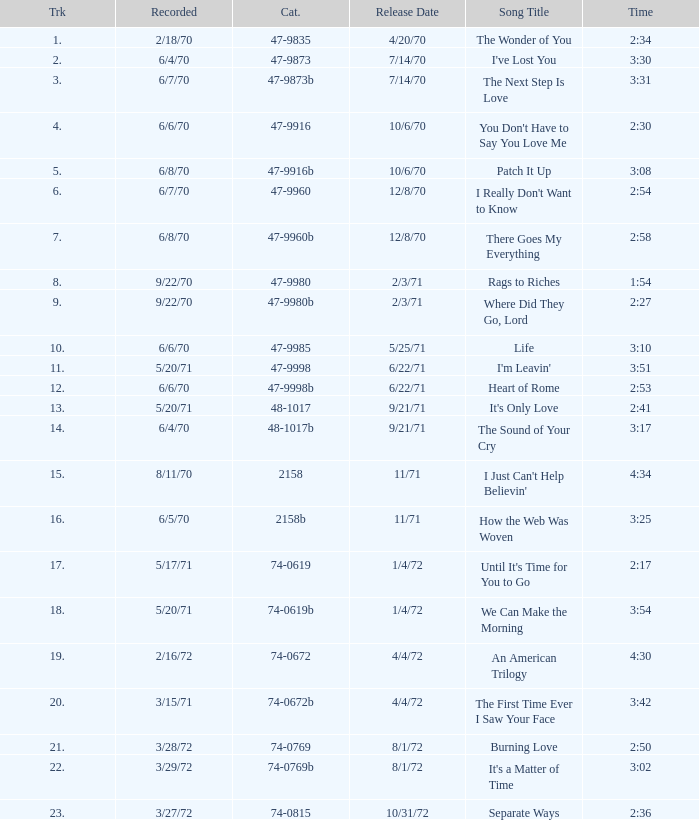Which song was released 12/8/70 with a time of 2:54? I Really Don't Want to Know. Parse the table in full. {'header': ['Trk', 'Recorded', 'Cat.', 'Release Date', 'Song Title', 'Time'], 'rows': [['1.', '2/18/70', '47-9835', '4/20/70', 'The Wonder of You', '2:34'], ['2.', '6/4/70', '47-9873', '7/14/70', "I've Lost You", '3:30'], ['3.', '6/7/70', '47-9873b', '7/14/70', 'The Next Step Is Love', '3:31'], ['4.', '6/6/70', '47-9916', '10/6/70', "You Don't Have to Say You Love Me", '2:30'], ['5.', '6/8/70', '47-9916b', '10/6/70', 'Patch It Up', '3:08'], ['6.', '6/7/70', '47-9960', '12/8/70', "I Really Don't Want to Know", '2:54'], ['7.', '6/8/70', '47-9960b', '12/8/70', 'There Goes My Everything', '2:58'], ['8.', '9/22/70', '47-9980', '2/3/71', 'Rags to Riches', '1:54'], ['9.', '9/22/70', '47-9980b', '2/3/71', 'Where Did They Go, Lord', '2:27'], ['10.', '6/6/70', '47-9985', '5/25/71', 'Life', '3:10'], ['11.', '5/20/71', '47-9998', '6/22/71', "I'm Leavin'", '3:51'], ['12.', '6/6/70', '47-9998b', '6/22/71', 'Heart of Rome', '2:53'], ['13.', '5/20/71', '48-1017', '9/21/71', "It's Only Love", '2:41'], ['14.', '6/4/70', '48-1017b', '9/21/71', 'The Sound of Your Cry', '3:17'], ['15.', '8/11/70', '2158', '11/71', "I Just Can't Help Believin'", '4:34'], ['16.', '6/5/70', '2158b', '11/71', 'How the Web Was Woven', '3:25'], ['17.', '5/17/71', '74-0619', '1/4/72', "Until It's Time for You to Go", '2:17'], ['18.', '5/20/71', '74-0619b', '1/4/72', 'We Can Make the Morning', '3:54'], ['19.', '2/16/72', '74-0672', '4/4/72', 'An American Trilogy', '4:30'], ['20.', '3/15/71', '74-0672b', '4/4/72', 'The First Time Ever I Saw Your Face', '3:42'], ['21.', '3/28/72', '74-0769', '8/1/72', 'Burning Love', '2:50'], ['22.', '3/29/72', '74-0769b', '8/1/72', "It's a Matter of Time", '3:02'], ['23.', '3/27/72', '74-0815', '10/31/72', 'Separate Ways', '2:36']]} 